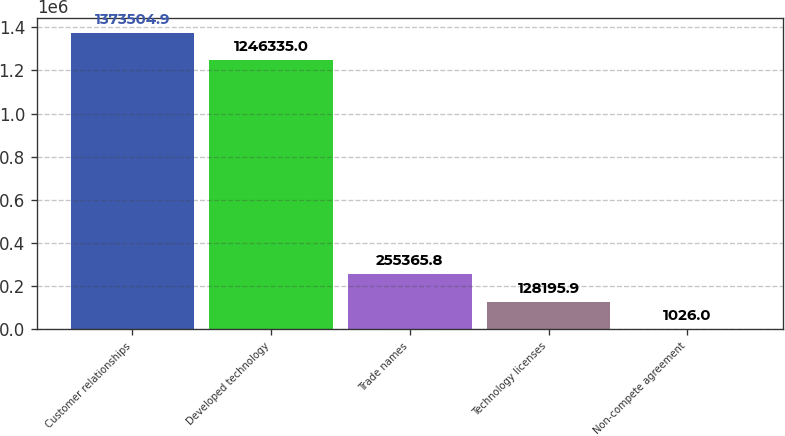<chart> <loc_0><loc_0><loc_500><loc_500><bar_chart><fcel>Customer relationships<fcel>Developed technology<fcel>Trade names<fcel>Technology licenses<fcel>Non-compete agreement<nl><fcel>1.3735e+06<fcel>1.24634e+06<fcel>255366<fcel>128196<fcel>1026<nl></chart> 